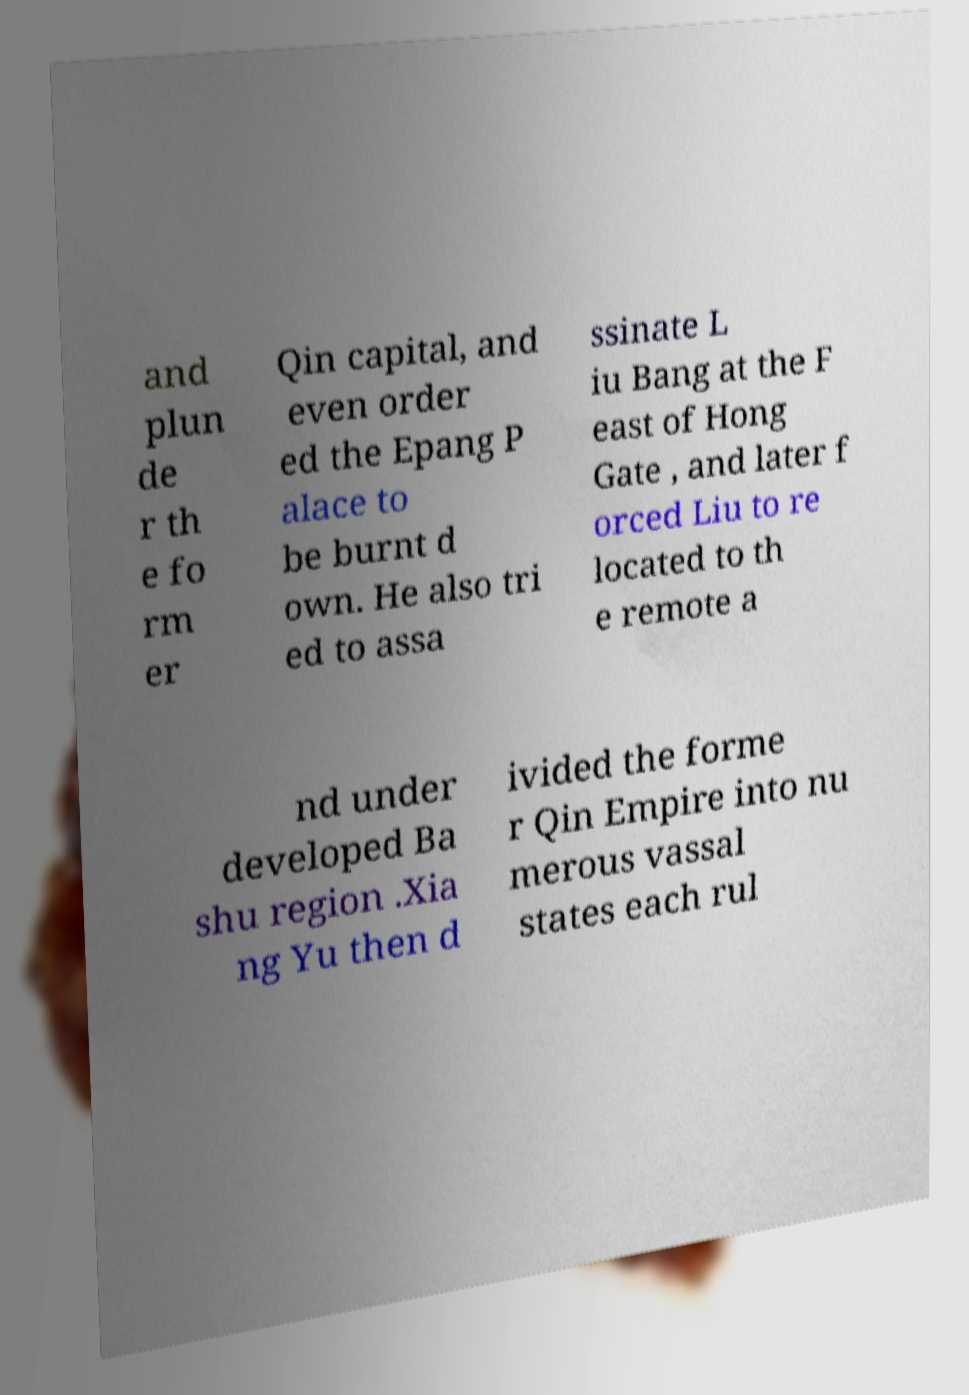There's text embedded in this image that I need extracted. Can you transcribe it verbatim? and plun de r th e fo rm er Qin capital, and even order ed the Epang P alace to be burnt d own. He also tri ed to assa ssinate L iu Bang at the F east of Hong Gate , and later f orced Liu to re located to th e remote a nd under developed Ba shu region .Xia ng Yu then d ivided the forme r Qin Empire into nu merous vassal states each rul 